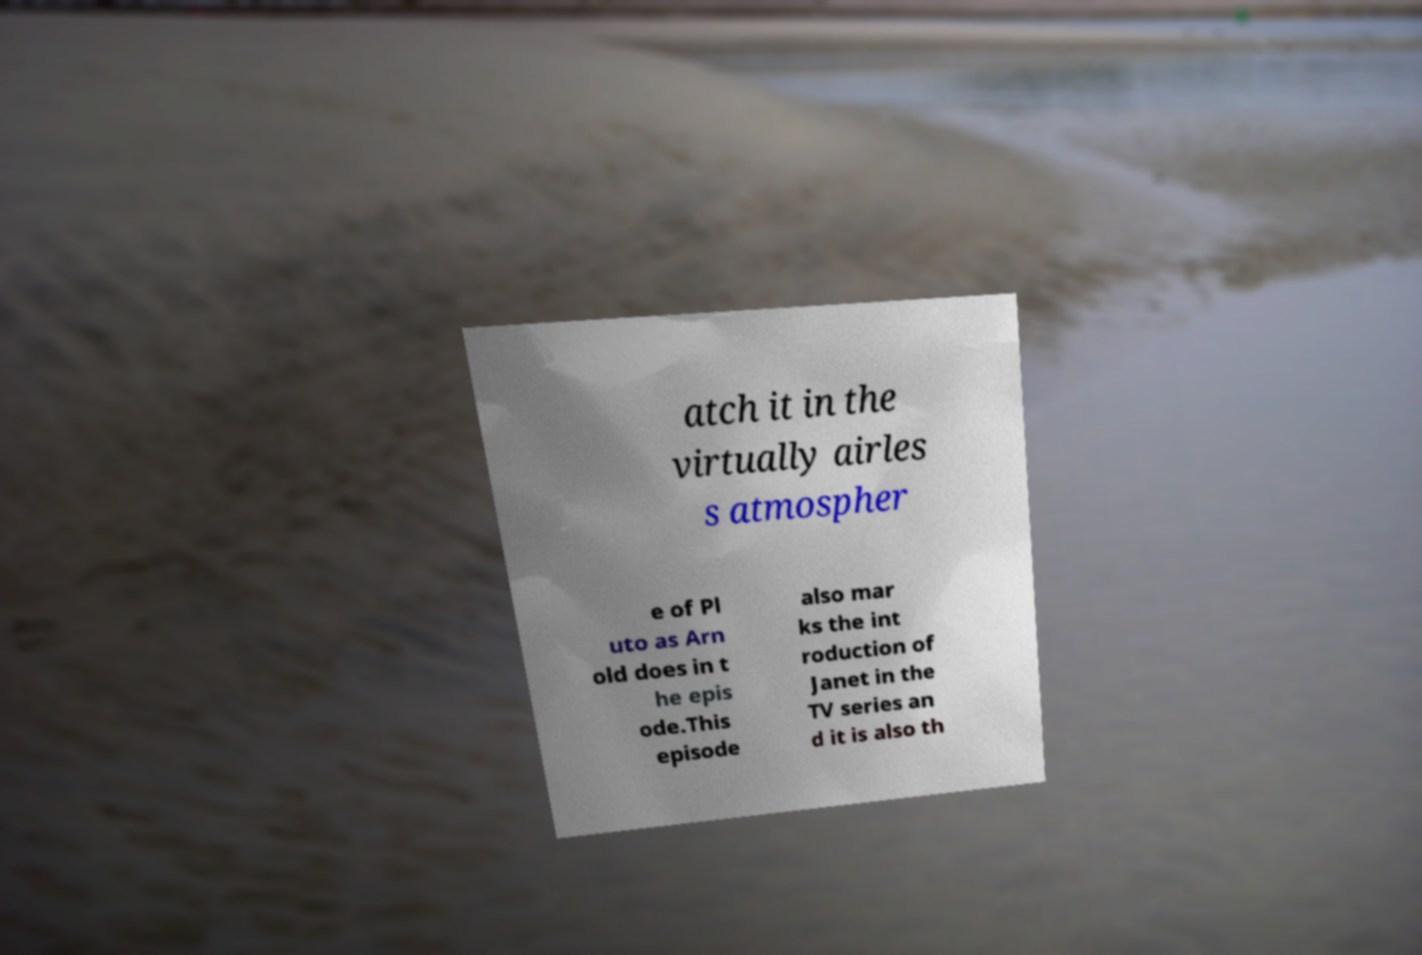Please read and relay the text visible in this image. What does it say? atch it in the virtually airles s atmospher e of Pl uto as Arn old does in t he epis ode.This episode also mar ks the int roduction of Janet in the TV series an d it is also th 